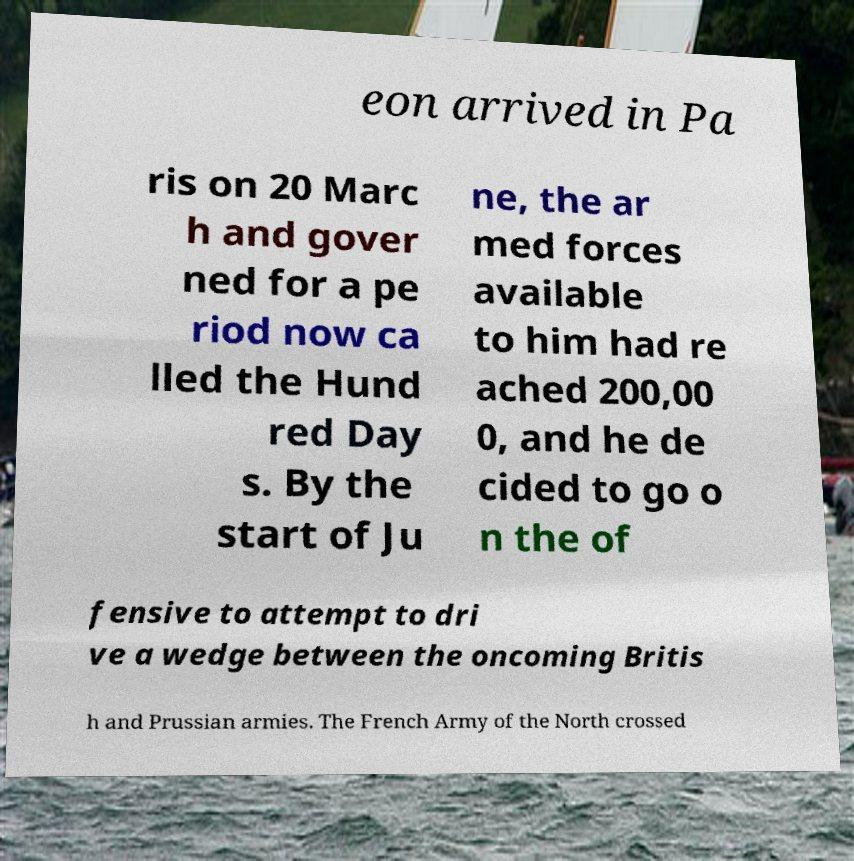There's text embedded in this image that I need extracted. Can you transcribe it verbatim? eon arrived in Pa ris on 20 Marc h and gover ned for a pe riod now ca lled the Hund red Day s. By the start of Ju ne, the ar med forces available to him had re ached 200,00 0, and he de cided to go o n the of fensive to attempt to dri ve a wedge between the oncoming Britis h and Prussian armies. The French Army of the North crossed 